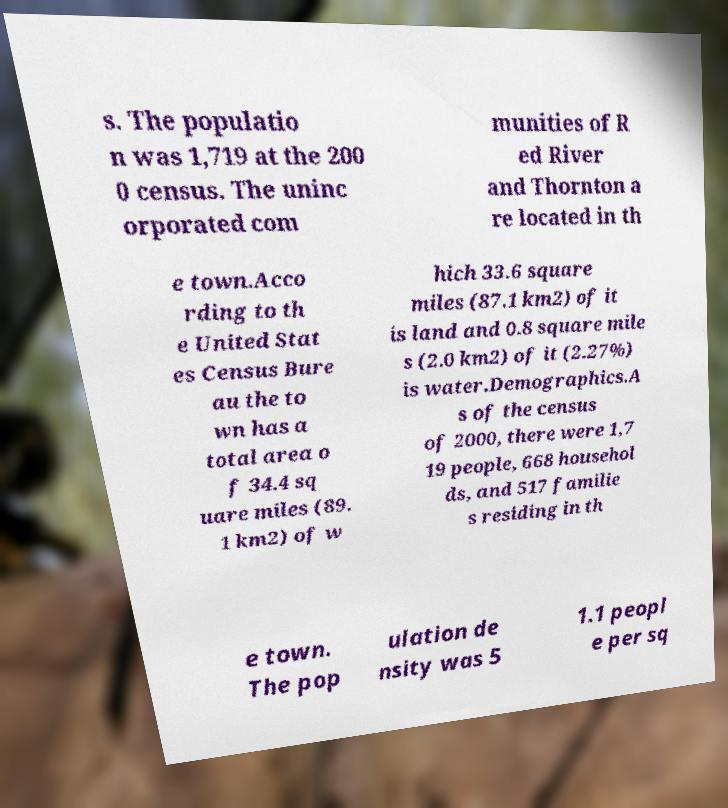For documentation purposes, I need the text within this image transcribed. Could you provide that? s. The populatio n was 1,719 at the 200 0 census. The uninc orporated com munities of R ed River and Thornton a re located in th e town.Acco rding to th e United Stat es Census Bure au the to wn has a total area o f 34.4 sq uare miles (89. 1 km2) of w hich 33.6 square miles (87.1 km2) of it is land and 0.8 square mile s (2.0 km2) of it (2.27%) is water.Demographics.A s of the census of 2000, there were 1,7 19 people, 668 househol ds, and 517 familie s residing in th e town. The pop ulation de nsity was 5 1.1 peopl e per sq 